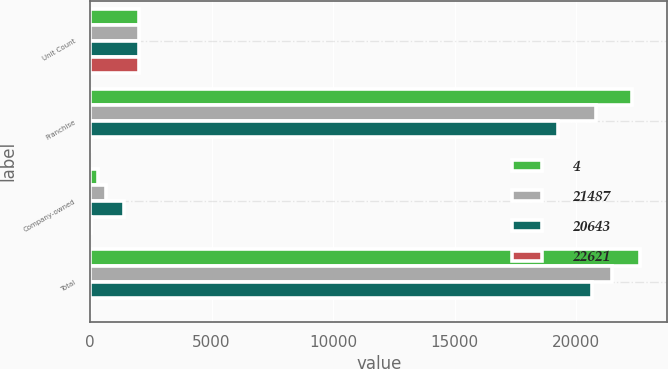Convert chart. <chart><loc_0><loc_0><loc_500><loc_500><stacked_bar_chart><ecel><fcel>Unit Count<fcel>Franchise<fcel>Company-owned<fcel>Total<nl><fcel>4<fcel>2018<fcel>22297<fcel>324<fcel>22621<nl><fcel>21487<fcel>2017<fcel>20819<fcel>668<fcel>21487<nl><fcel>20643<fcel>2016<fcel>19236<fcel>1407<fcel>20643<nl><fcel>22621<fcel>2018<fcel>7<fcel>51<fcel>5<nl></chart> 